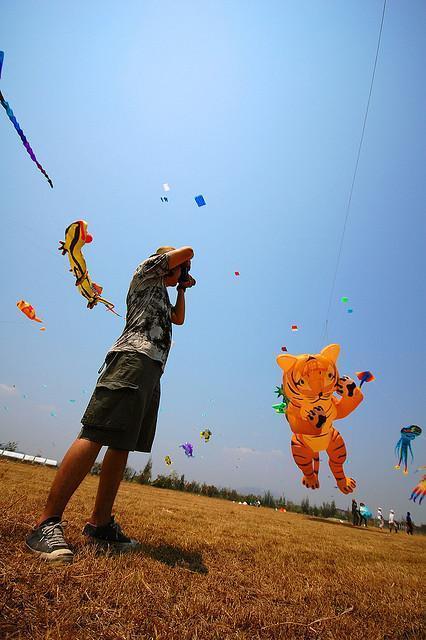How many kites can you see?
Give a very brief answer. 2. 